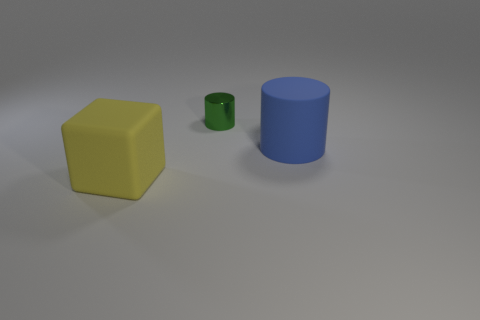What number of other things are there of the same color as the large cylinder?
Make the answer very short. 0. There is a object that is the same size as the matte cube; what is its shape?
Offer a very short reply. Cylinder. There is a rubber thing to the right of the cylinder that is behind the blue matte cylinder; how many large blue objects are behind it?
Give a very brief answer. 0. What number of matte objects are large blocks or green objects?
Your response must be concise. 1. What color is the thing that is in front of the small green metal thing and to the left of the blue matte cylinder?
Keep it short and to the point. Yellow. Is the size of the thing in front of the blue thing the same as the blue thing?
Provide a short and direct response. Yes. What number of things are big things that are behind the matte cube or large blue objects?
Keep it short and to the point. 1. Is there a green cylinder of the same size as the blue thing?
Your answer should be very brief. No. There is a thing that is the same size as the matte cylinder; what material is it?
Your response must be concise. Rubber. What shape is the thing that is to the left of the blue thing and to the right of the big cube?
Your answer should be compact. Cylinder. 